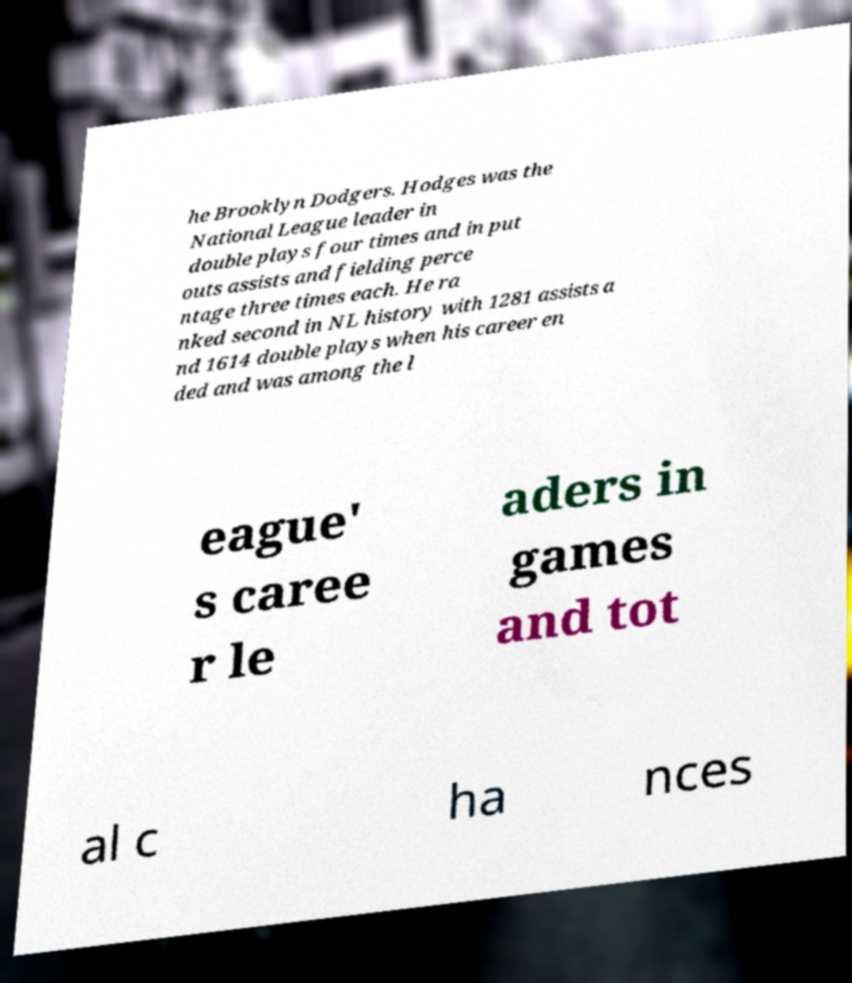Please identify and transcribe the text found in this image. he Brooklyn Dodgers. Hodges was the National League leader in double plays four times and in put outs assists and fielding perce ntage three times each. He ra nked second in NL history with 1281 assists a nd 1614 double plays when his career en ded and was among the l eague' s caree r le aders in games and tot al c ha nces 